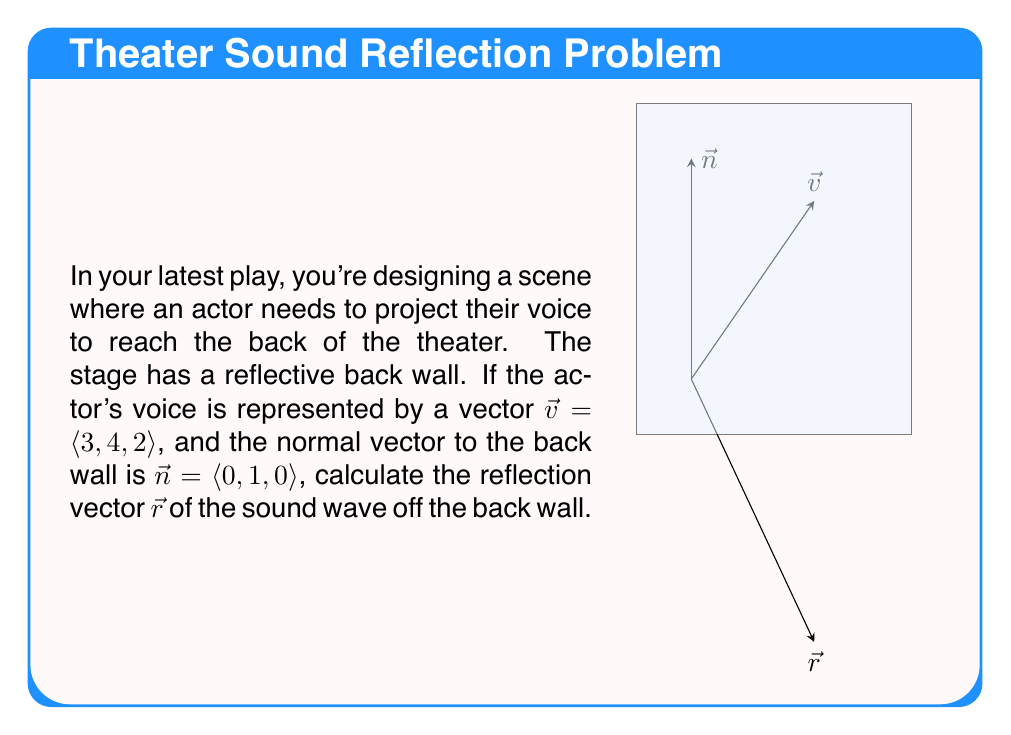Solve this math problem. To find the reflection vector $\vec{r}$, we can use the vector reflection formula:

$$\vec{r} = \vec{v} - 2(\vec{v} \cdot \hat{n})\hat{n}$$

Where $\hat{n}$ is the unit normal vector.

Step 1: Normalize $\vec{n}$ to get $\hat{n}$
$\vec{n} = \langle 0, 1, 0 \rangle$ is already a unit vector, so $\hat{n} = \langle 0, 1, 0 \rangle$

Step 2: Calculate $\vec{v} \cdot \hat{n}$
$$\vec{v} \cdot \hat{n} = 3(0) + 4(1) + 2(0) = 4$$

Step 3: Calculate $2(\vec{v} \cdot \hat{n})\hat{n}$
$$2(\vec{v} \cdot \hat{n})\hat{n} = 2(4)\langle 0, 1, 0 \rangle = \langle 0, 8, 0 \rangle$$

Step 4: Subtract from $\vec{v}$
$$\vec{r} = \vec{v} - 2(\vec{v} \cdot \hat{n})\hat{n} = \langle 3, 4, 2 \rangle - \langle 0, 8, 0 \rangle = \langle 3, -4, 2 \rangle$$

Therefore, the reflection vector $\vec{r}$ is $\langle 3, -4, 2 \rangle$.
Answer: $\langle 3, -4, 2 \rangle$ 